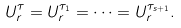<formula> <loc_0><loc_0><loc_500><loc_500>U _ { r } ^ { \tau } = U _ { r } ^ { \tau _ { 1 } } = \cdots = U _ { r } ^ { \tau _ { s + 1 } } .</formula> 